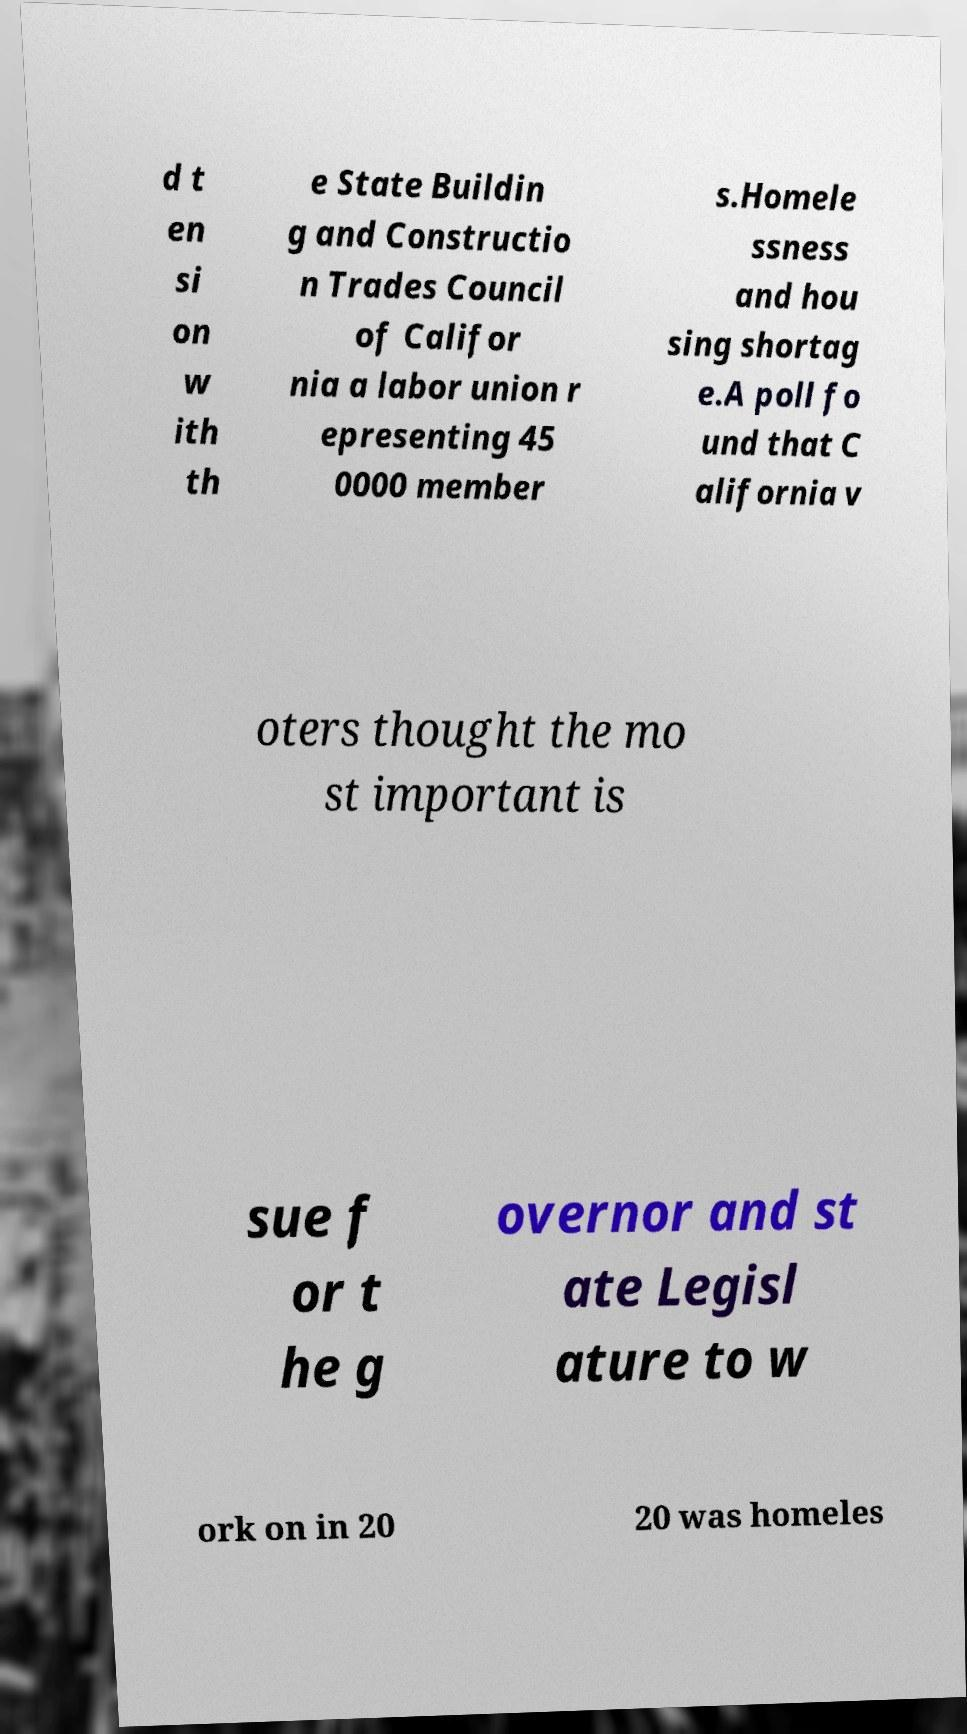Could you extract and type out the text from this image? d t en si on w ith th e State Buildin g and Constructio n Trades Council of Califor nia a labor union r epresenting 45 0000 member s.Homele ssness and hou sing shortag e.A poll fo und that C alifornia v oters thought the mo st important is sue f or t he g overnor and st ate Legisl ature to w ork on in 20 20 was homeles 